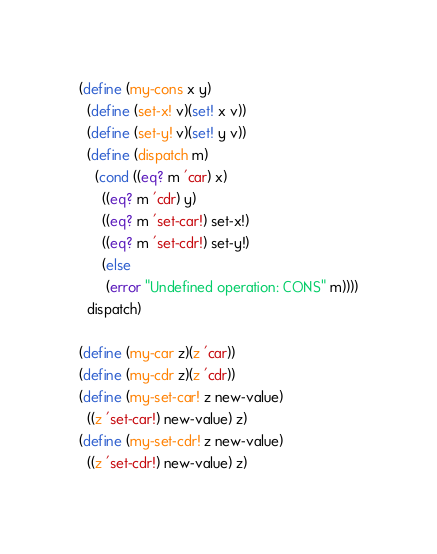Convert code to text. <code><loc_0><loc_0><loc_500><loc_500><_Scheme_>(define (my-cons x y)
  (define (set-x! v)(set! x v))
  (define (set-y! v)(set! y v))
  (define (dispatch m)
    (cond ((eq? m 'car) x)
	  ((eq? m 'cdr) y)
	  ((eq? m 'set-car!) set-x!)
	  ((eq? m 'set-cdr!) set-y!)
	  (else
	   (error "Undefined operation: CONS" m))))
  dispatch)

(define (my-car z)(z 'car))
(define (my-cdr z)(z 'cdr))
(define (my-set-car! z new-value)
  ((z 'set-car!) new-value) z)
(define (my-set-cdr! z new-value)
  ((z 'set-cdr!) new-value) z)

</code> 